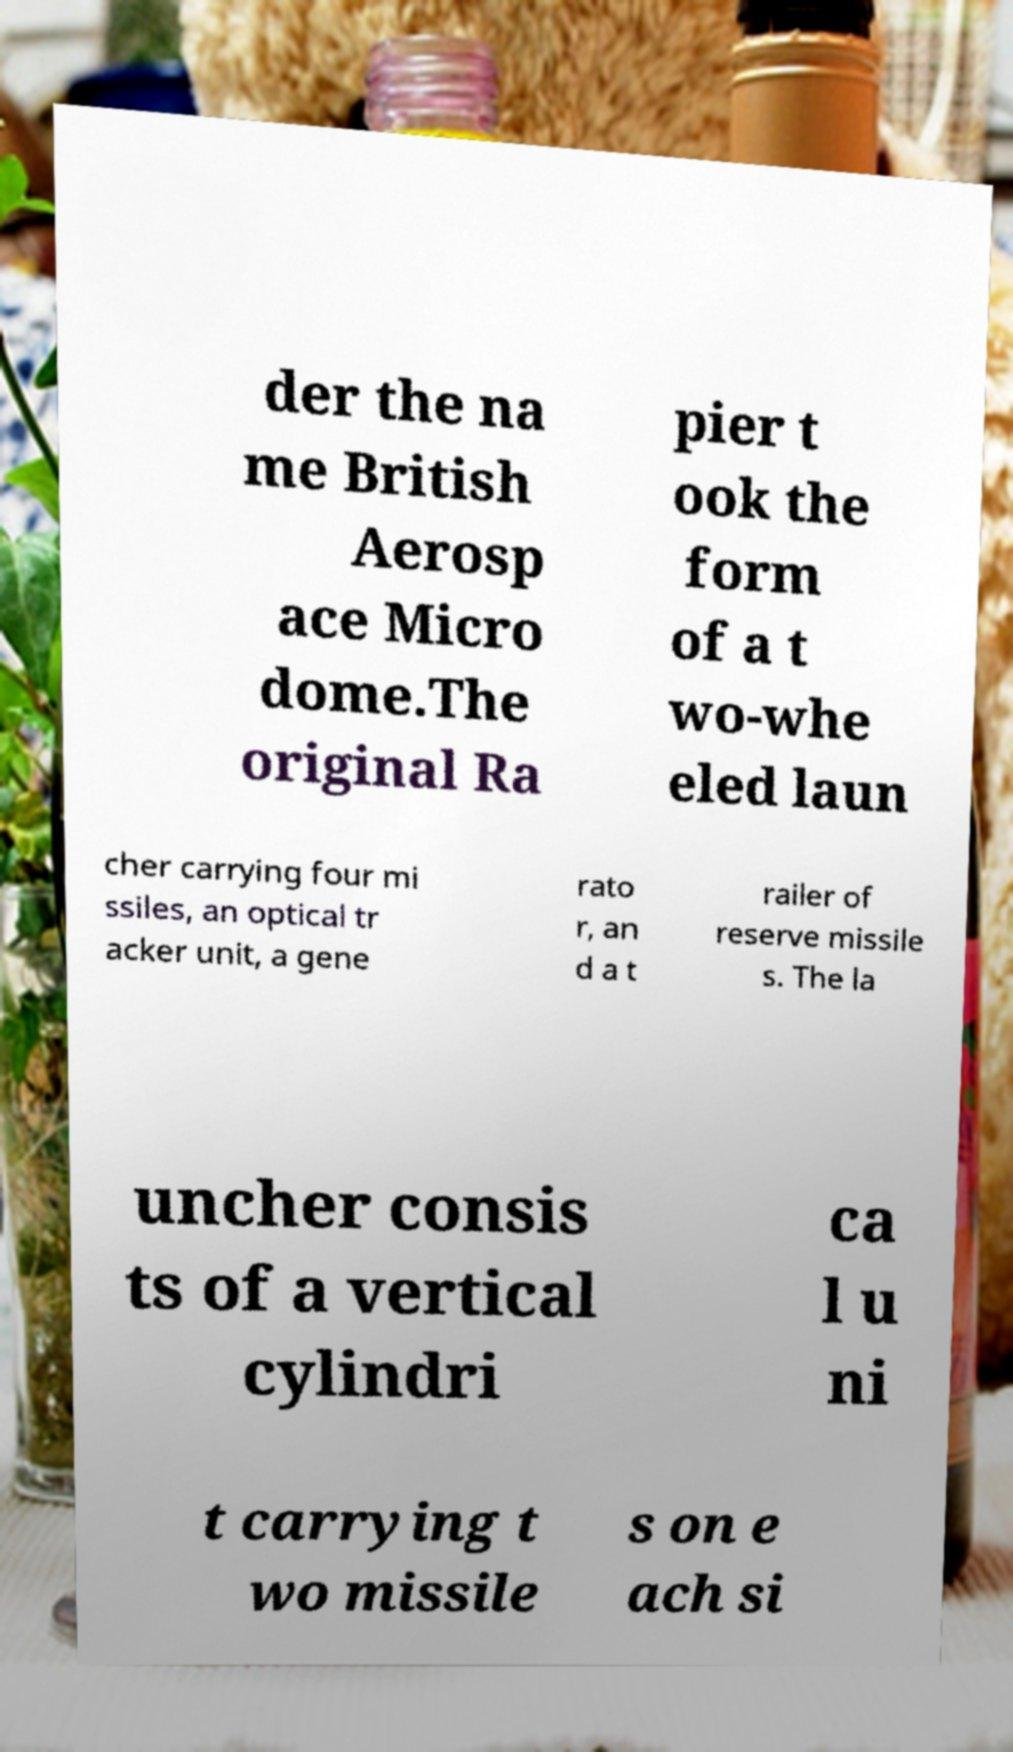Can you read and provide the text displayed in the image?This photo seems to have some interesting text. Can you extract and type it out for me? der the na me British Aerosp ace Micro dome.The original Ra pier t ook the form of a t wo-whe eled laun cher carrying four mi ssiles, an optical tr acker unit, a gene rato r, an d a t railer of reserve missile s. The la uncher consis ts of a vertical cylindri ca l u ni t carrying t wo missile s on e ach si 